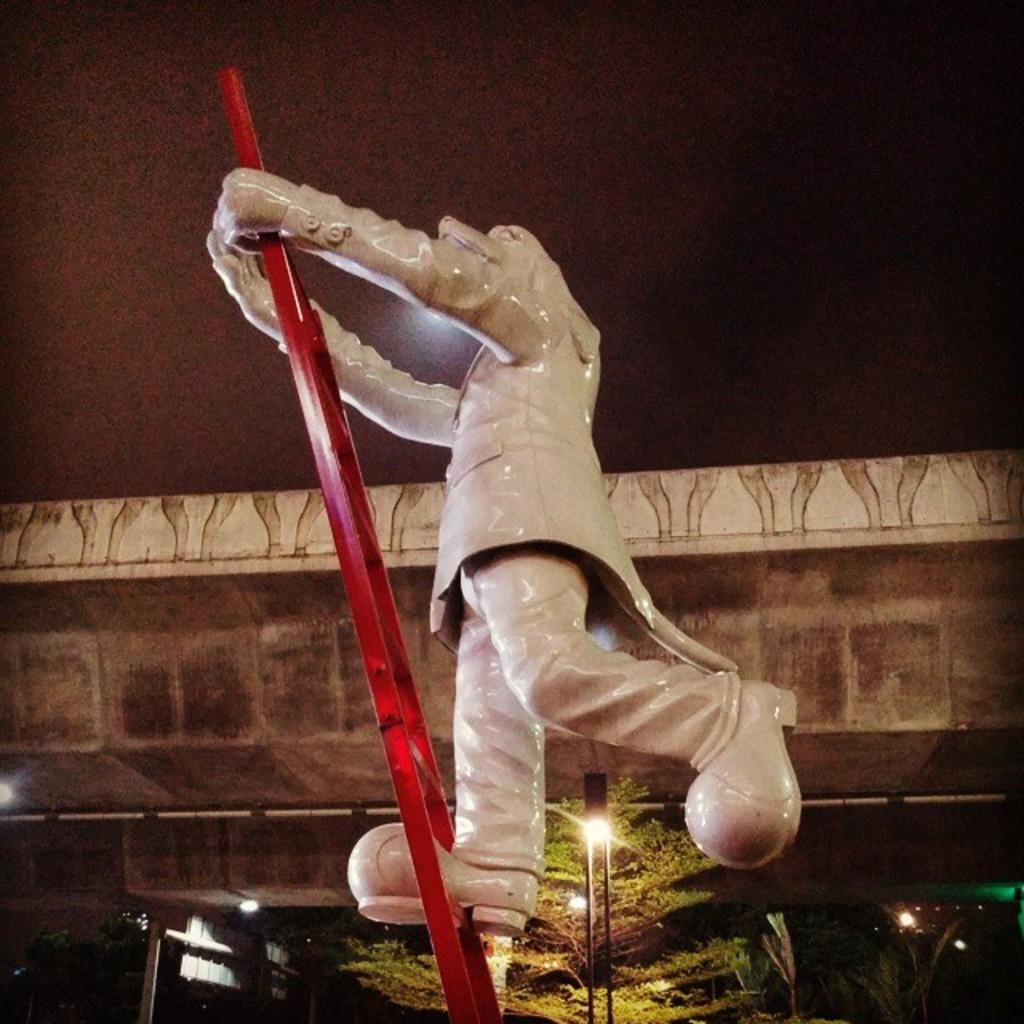What is the main subject in the foreground of the image? There is a sculpture on a red ladder in the foreground of the image. What can be seen in the background of the image? There is a street pole, trees, a bridge, and a dark sky in the background of the image. How does the jelly contribute to the division in the image? There is no jelly present in the image, so it cannot contribute to any division. 